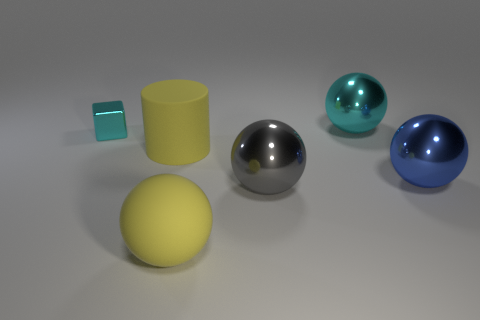Subtract 1 balls. How many balls are left? 3 Subtract all cyan balls. How many balls are left? 3 Add 1 cyan metallic things. How many objects exist? 7 Subtract all brown spheres. Subtract all purple cylinders. How many spheres are left? 4 Subtract all cubes. How many objects are left? 5 Add 4 large cyan objects. How many large cyan objects are left? 5 Add 1 large purple matte cylinders. How many large purple matte cylinders exist? 1 Subtract 0 green balls. How many objects are left? 6 Subtract all big yellow objects. Subtract all small metallic cubes. How many objects are left? 3 